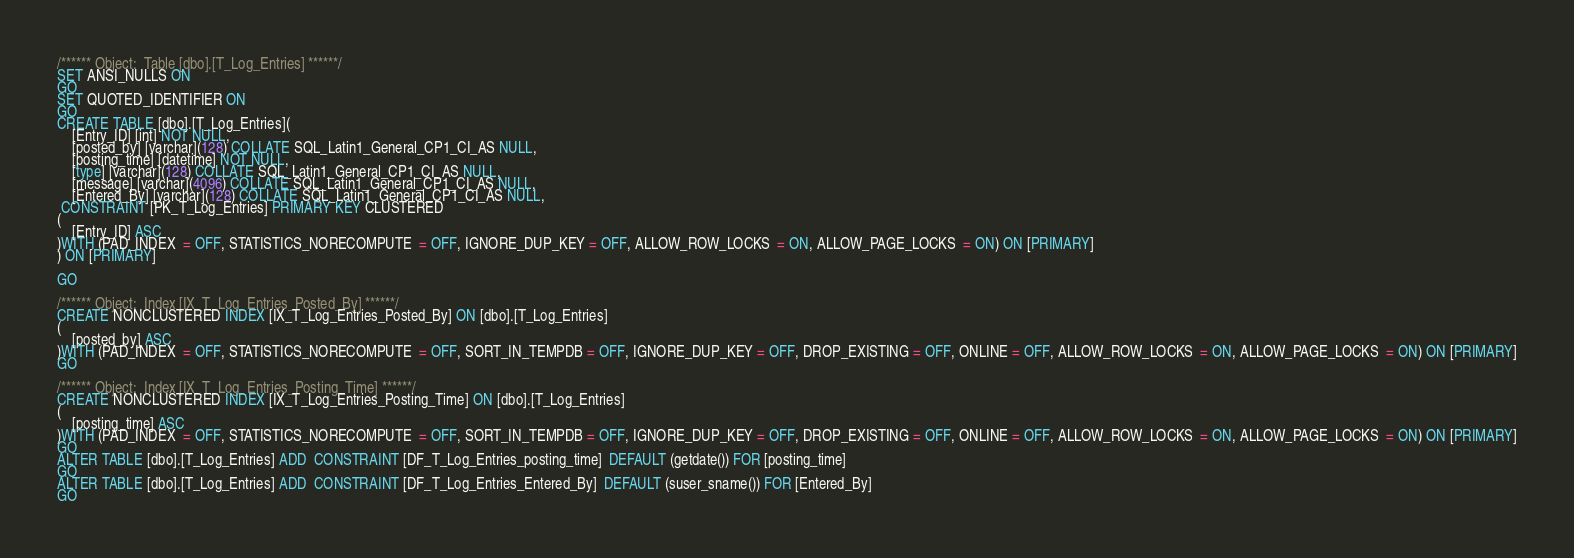<code> <loc_0><loc_0><loc_500><loc_500><_SQL_>/****** Object:  Table [dbo].[T_Log_Entries] ******/
SET ANSI_NULLS ON
GO
SET QUOTED_IDENTIFIER ON
GO
CREATE TABLE [dbo].[T_Log_Entries](
	[Entry_ID] [int] NOT NULL,
	[posted_by] [varchar](128) COLLATE SQL_Latin1_General_CP1_CI_AS NULL,
	[posting_time] [datetime] NOT NULL,
	[type] [varchar](128) COLLATE SQL_Latin1_General_CP1_CI_AS NULL,
	[message] [varchar](4096) COLLATE SQL_Latin1_General_CP1_CI_AS NULL,
	[Entered_By] [varchar](128) COLLATE SQL_Latin1_General_CP1_CI_AS NULL,
 CONSTRAINT [PK_T_Log_Entries] PRIMARY KEY CLUSTERED 
(
	[Entry_ID] ASC
)WITH (PAD_INDEX  = OFF, STATISTICS_NORECOMPUTE  = OFF, IGNORE_DUP_KEY = OFF, ALLOW_ROW_LOCKS  = ON, ALLOW_PAGE_LOCKS  = ON) ON [PRIMARY]
) ON [PRIMARY]

GO

/****** Object:  Index [IX_T_Log_Entries_Posted_By] ******/
CREATE NONCLUSTERED INDEX [IX_T_Log_Entries_Posted_By] ON [dbo].[T_Log_Entries] 
(
	[posted_by] ASC
)WITH (PAD_INDEX  = OFF, STATISTICS_NORECOMPUTE  = OFF, SORT_IN_TEMPDB = OFF, IGNORE_DUP_KEY = OFF, DROP_EXISTING = OFF, ONLINE = OFF, ALLOW_ROW_LOCKS  = ON, ALLOW_PAGE_LOCKS  = ON) ON [PRIMARY]
GO

/****** Object:  Index [IX_T_Log_Entries_Posting_Time] ******/
CREATE NONCLUSTERED INDEX [IX_T_Log_Entries_Posting_Time] ON [dbo].[T_Log_Entries] 
(
	[posting_time] ASC
)WITH (PAD_INDEX  = OFF, STATISTICS_NORECOMPUTE  = OFF, SORT_IN_TEMPDB = OFF, IGNORE_DUP_KEY = OFF, DROP_EXISTING = OFF, ONLINE = OFF, ALLOW_ROW_LOCKS  = ON, ALLOW_PAGE_LOCKS  = ON) ON [PRIMARY]
GO
ALTER TABLE [dbo].[T_Log_Entries] ADD  CONSTRAINT [DF_T_Log_Entries_posting_time]  DEFAULT (getdate()) FOR [posting_time]
GO
ALTER TABLE [dbo].[T_Log_Entries] ADD  CONSTRAINT [DF_T_Log_Entries_Entered_By]  DEFAULT (suser_sname()) FOR [Entered_By]
GO
</code> 